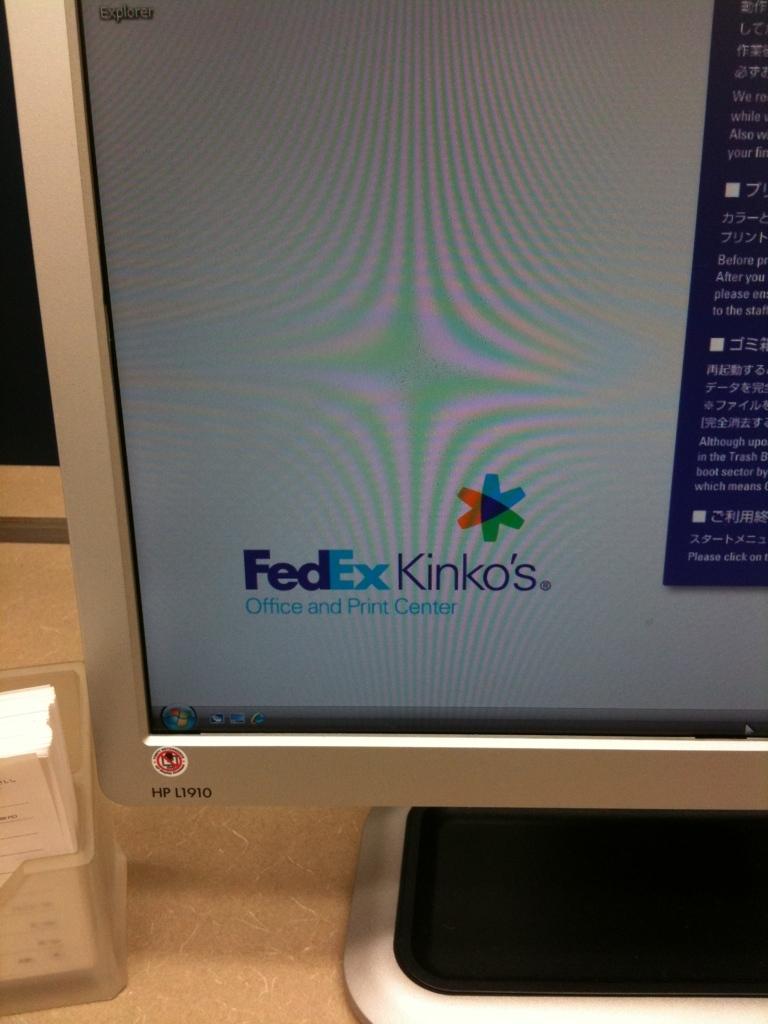What shipping company name is known?
Offer a terse response. Fedex. What is the store name?
Offer a very short reply. Fedex kinko's. 